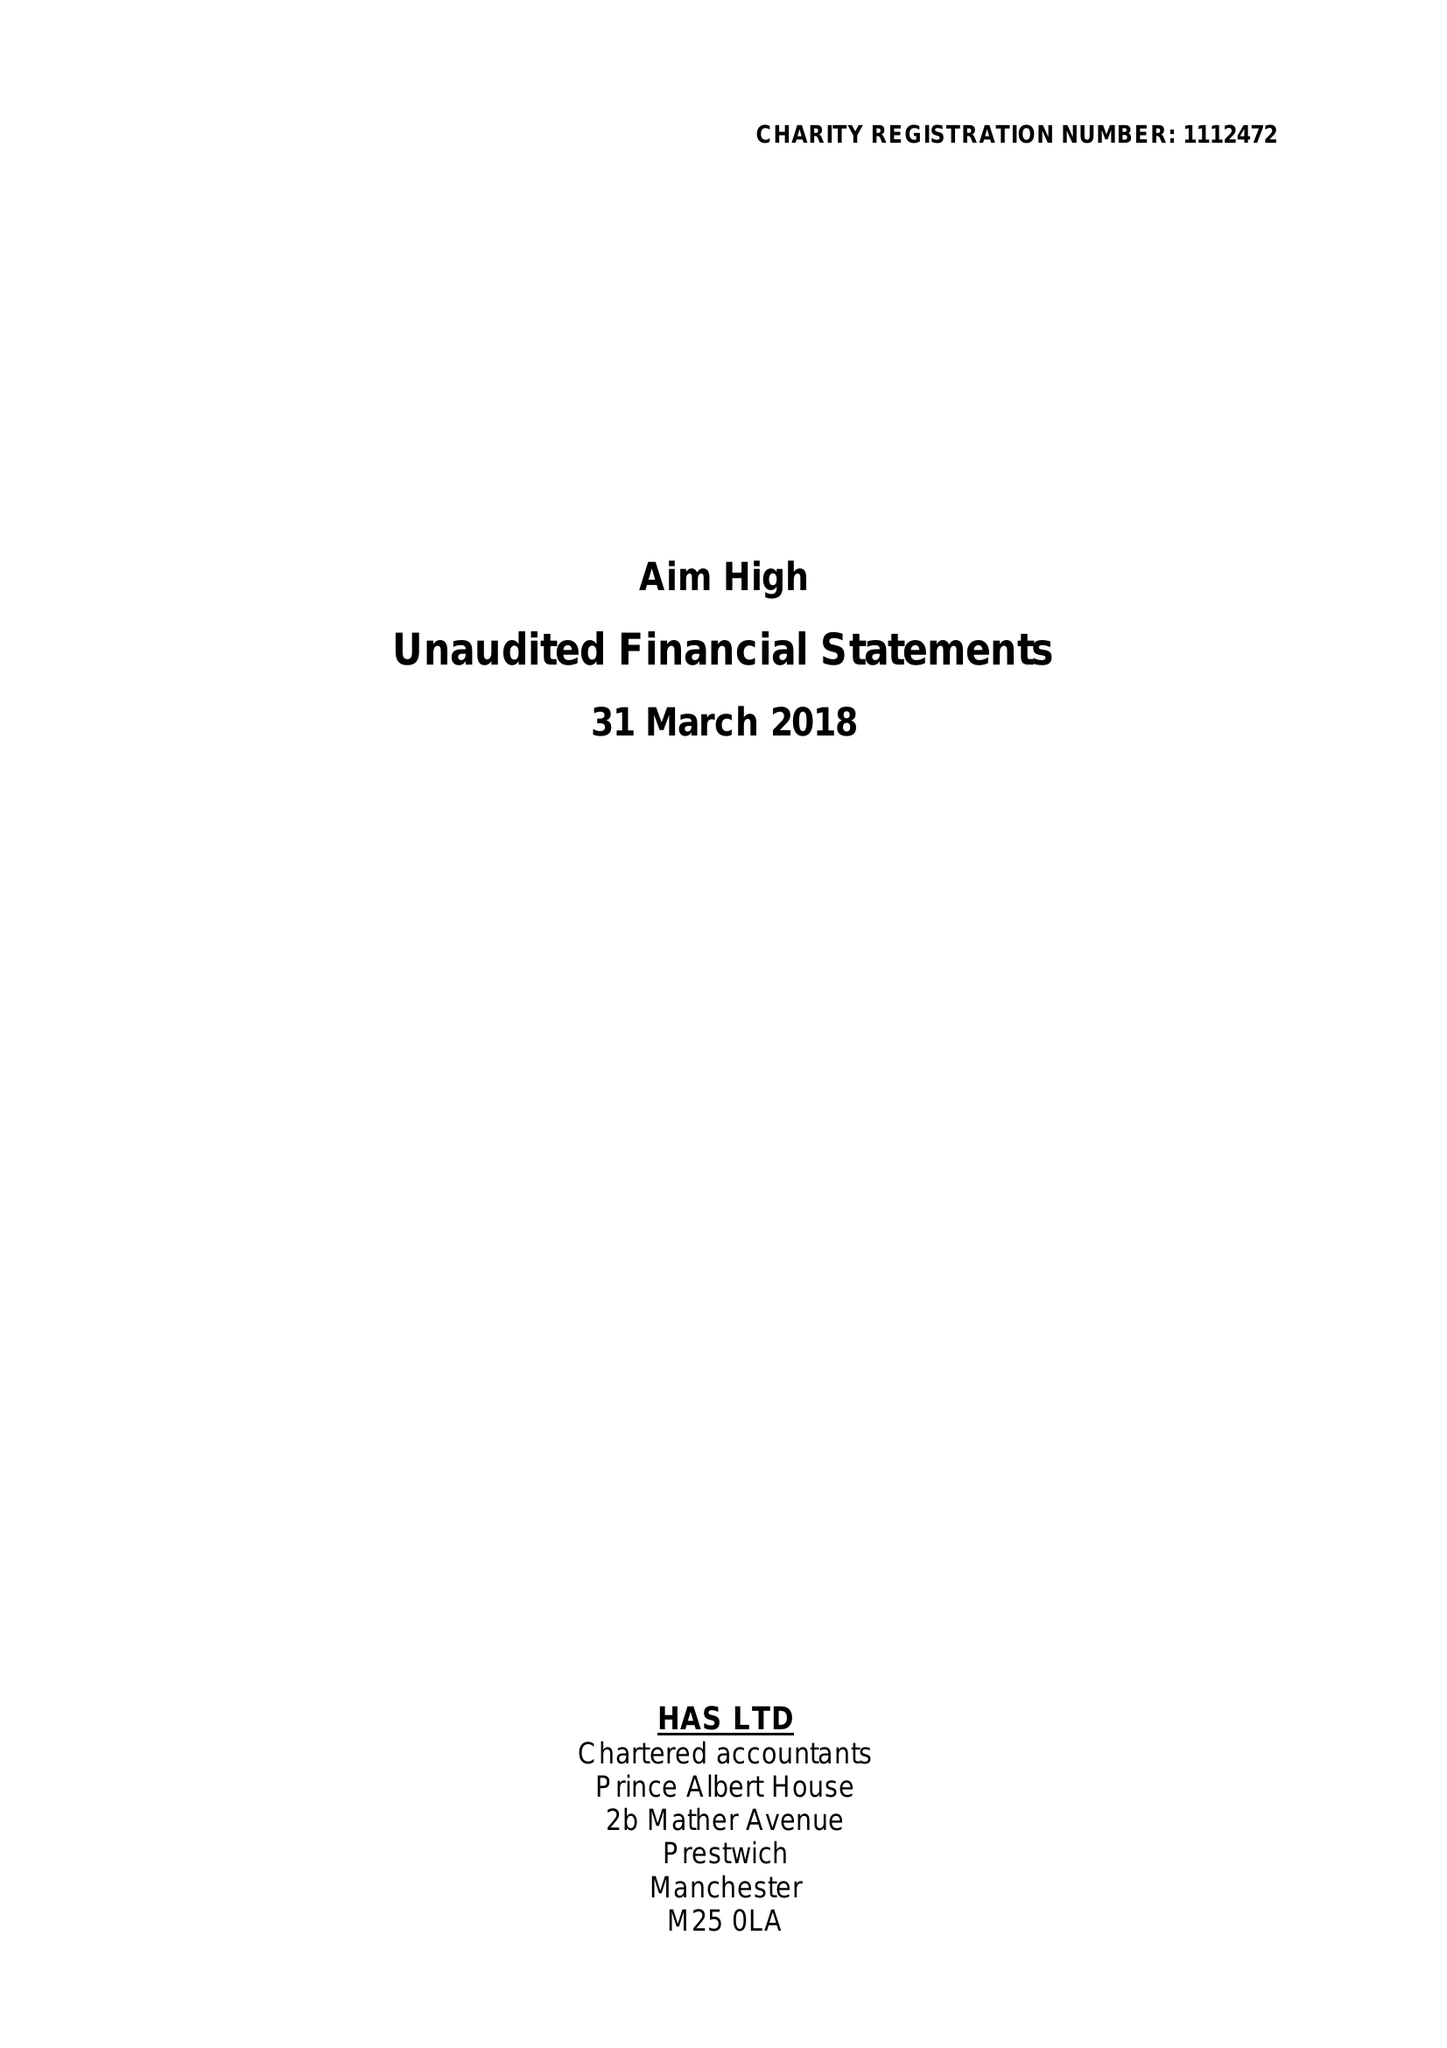What is the value for the spending_annually_in_british_pounds?
Answer the question using a single word or phrase. 54440.00 